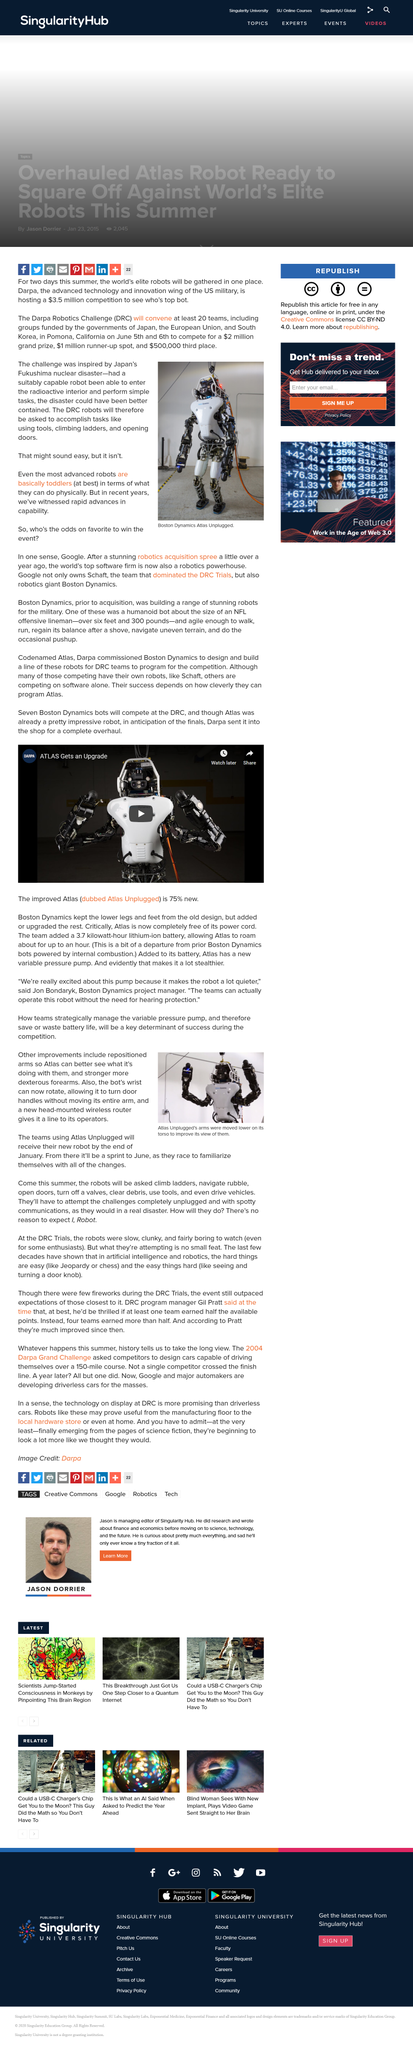Highlight a few significant elements in this photo. Atlas Unplugged is a robot that is a fully autonomous, multi-talented mobile manipulator with advanced sensing, navigation, and manipulation capabilities, designed to operate in complex and dynamic environments. Atlas Unplugged's arms were moved in order to enhance its visual perception of them. The caption indicates that the photo depicts a Boston Dynamics Atlas robot that is unplugged. Google owns Boston Dynamics, a leading robotics company. The wireless router is located on the Atlas Unplugged. It is placed on its head. 